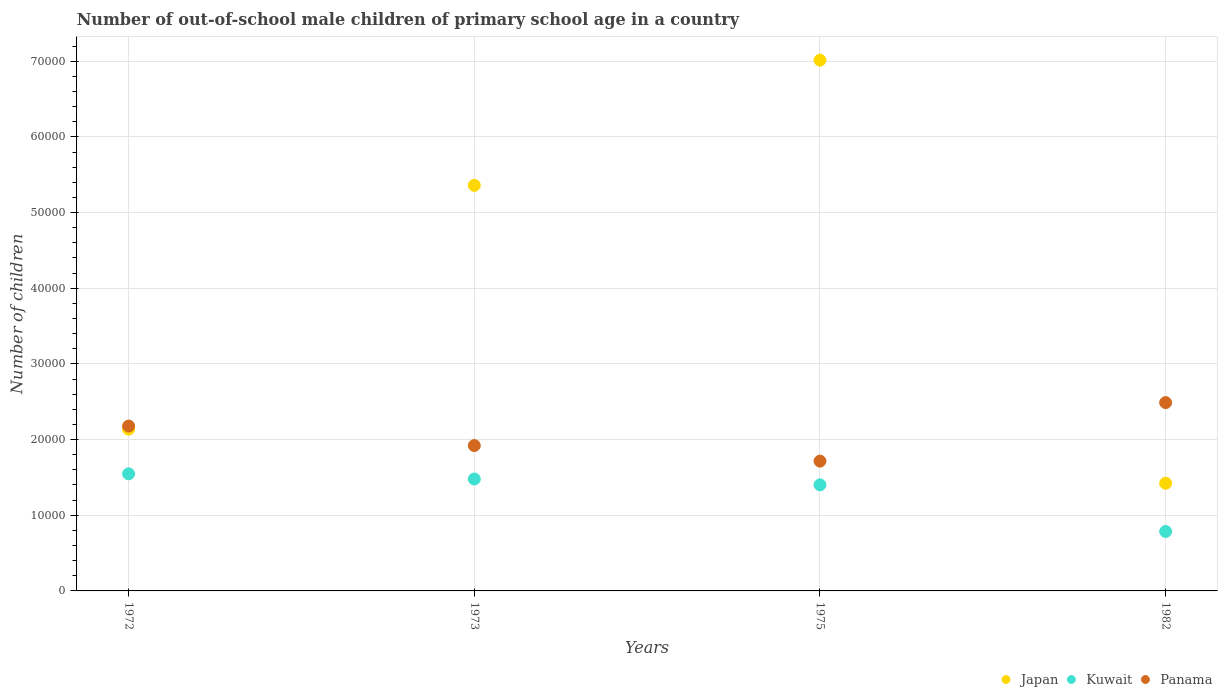Is the number of dotlines equal to the number of legend labels?
Provide a succinct answer. Yes. What is the number of out-of-school male children in Panama in 1975?
Keep it short and to the point. 1.72e+04. Across all years, what is the maximum number of out-of-school male children in Panama?
Ensure brevity in your answer.  2.49e+04. Across all years, what is the minimum number of out-of-school male children in Japan?
Provide a succinct answer. 1.42e+04. In which year was the number of out-of-school male children in Japan maximum?
Ensure brevity in your answer.  1975. In which year was the number of out-of-school male children in Panama minimum?
Offer a very short reply. 1975. What is the total number of out-of-school male children in Panama in the graph?
Offer a terse response. 8.30e+04. What is the difference between the number of out-of-school male children in Kuwait in 1975 and that in 1982?
Give a very brief answer. 6163. What is the difference between the number of out-of-school male children in Panama in 1973 and the number of out-of-school male children in Kuwait in 1972?
Make the answer very short. 3737. What is the average number of out-of-school male children in Kuwait per year?
Your answer should be very brief. 1.30e+04. In the year 1975, what is the difference between the number of out-of-school male children in Panama and number of out-of-school male children in Japan?
Keep it short and to the point. -5.30e+04. In how many years, is the number of out-of-school male children in Panama greater than 50000?
Offer a very short reply. 0. What is the ratio of the number of out-of-school male children in Japan in 1973 to that in 1982?
Your answer should be very brief. 3.77. Is the number of out-of-school male children in Panama in 1973 less than that in 1982?
Provide a short and direct response. Yes. Is the difference between the number of out-of-school male children in Panama in 1975 and 1982 greater than the difference between the number of out-of-school male children in Japan in 1975 and 1982?
Your response must be concise. No. What is the difference between the highest and the second highest number of out-of-school male children in Japan?
Your answer should be very brief. 1.65e+04. What is the difference between the highest and the lowest number of out-of-school male children in Panama?
Offer a very short reply. 7733. In how many years, is the number of out-of-school male children in Panama greater than the average number of out-of-school male children in Panama taken over all years?
Your response must be concise. 2. Is the sum of the number of out-of-school male children in Panama in 1973 and 1975 greater than the maximum number of out-of-school male children in Kuwait across all years?
Give a very brief answer. Yes. How many dotlines are there?
Give a very brief answer. 3. How many years are there in the graph?
Provide a succinct answer. 4. Are the values on the major ticks of Y-axis written in scientific E-notation?
Your response must be concise. No. Does the graph contain any zero values?
Ensure brevity in your answer.  No. Does the graph contain grids?
Offer a terse response. Yes. How many legend labels are there?
Your answer should be compact. 3. How are the legend labels stacked?
Provide a short and direct response. Horizontal. What is the title of the graph?
Your response must be concise. Number of out-of-school male children of primary school age in a country. Does "Philippines" appear as one of the legend labels in the graph?
Ensure brevity in your answer.  No. What is the label or title of the X-axis?
Provide a short and direct response. Years. What is the label or title of the Y-axis?
Provide a succinct answer. Number of children. What is the Number of children in Japan in 1972?
Your response must be concise. 2.14e+04. What is the Number of children in Kuwait in 1972?
Ensure brevity in your answer.  1.55e+04. What is the Number of children in Panama in 1972?
Offer a terse response. 2.18e+04. What is the Number of children of Japan in 1973?
Your answer should be compact. 5.36e+04. What is the Number of children of Kuwait in 1973?
Offer a terse response. 1.48e+04. What is the Number of children in Panama in 1973?
Offer a terse response. 1.92e+04. What is the Number of children in Japan in 1975?
Offer a terse response. 7.01e+04. What is the Number of children in Kuwait in 1975?
Offer a terse response. 1.40e+04. What is the Number of children in Panama in 1975?
Your response must be concise. 1.72e+04. What is the Number of children in Japan in 1982?
Make the answer very short. 1.42e+04. What is the Number of children of Kuwait in 1982?
Provide a succinct answer. 7856. What is the Number of children of Panama in 1982?
Your answer should be compact. 2.49e+04. Across all years, what is the maximum Number of children of Japan?
Your response must be concise. 7.01e+04. Across all years, what is the maximum Number of children of Kuwait?
Your answer should be compact. 1.55e+04. Across all years, what is the maximum Number of children in Panama?
Offer a terse response. 2.49e+04. Across all years, what is the minimum Number of children in Japan?
Keep it short and to the point. 1.42e+04. Across all years, what is the minimum Number of children in Kuwait?
Keep it short and to the point. 7856. Across all years, what is the minimum Number of children of Panama?
Provide a short and direct response. 1.72e+04. What is the total Number of children of Japan in the graph?
Make the answer very short. 1.59e+05. What is the total Number of children in Kuwait in the graph?
Your answer should be very brief. 5.21e+04. What is the total Number of children in Panama in the graph?
Your answer should be compact. 8.30e+04. What is the difference between the Number of children of Japan in 1972 and that in 1973?
Provide a succinct answer. -3.22e+04. What is the difference between the Number of children of Kuwait in 1972 and that in 1973?
Provide a short and direct response. 681. What is the difference between the Number of children of Panama in 1972 and that in 1973?
Provide a short and direct response. 2577. What is the difference between the Number of children in Japan in 1972 and that in 1975?
Provide a short and direct response. -4.88e+04. What is the difference between the Number of children in Kuwait in 1972 and that in 1975?
Provide a succinct answer. 1454. What is the difference between the Number of children of Panama in 1972 and that in 1975?
Make the answer very short. 4635. What is the difference between the Number of children of Japan in 1972 and that in 1982?
Make the answer very short. 7146. What is the difference between the Number of children of Kuwait in 1972 and that in 1982?
Ensure brevity in your answer.  7617. What is the difference between the Number of children in Panama in 1972 and that in 1982?
Your response must be concise. -3098. What is the difference between the Number of children of Japan in 1973 and that in 1975?
Keep it short and to the point. -1.65e+04. What is the difference between the Number of children in Kuwait in 1973 and that in 1975?
Your response must be concise. 773. What is the difference between the Number of children in Panama in 1973 and that in 1975?
Offer a terse response. 2058. What is the difference between the Number of children in Japan in 1973 and that in 1982?
Ensure brevity in your answer.  3.94e+04. What is the difference between the Number of children in Kuwait in 1973 and that in 1982?
Offer a very short reply. 6936. What is the difference between the Number of children of Panama in 1973 and that in 1982?
Provide a succinct answer. -5675. What is the difference between the Number of children in Japan in 1975 and that in 1982?
Offer a very short reply. 5.59e+04. What is the difference between the Number of children in Kuwait in 1975 and that in 1982?
Provide a short and direct response. 6163. What is the difference between the Number of children of Panama in 1975 and that in 1982?
Your response must be concise. -7733. What is the difference between the Number of children in Japan in 1972 and the Number of children in Kuwait in 1973?
Make the answer very short. 6585. What is the difference between the Number of children in Japan in 1972 and the Number of children in Panama in 1973?
Make the answer very short. 2167. What is the difference between the Number of children of Kuwait in 1972 and the Number of children of Panama in 1973?
Your answer should be compact. -3737. What is the difference between the Number of children of Japan in 1972 and the Number of children of Kuwait in 1975?
Keep it short and to the point. 7358. What is the difference between the Number of children of Japan in 1972 and the Number of children of Panama in 1975?
Provide a short and direct response. 4225. What is the difference between the Number of children in Kuwait in 1972 and the Number of children in Panama in 1975?
Offer a terse response. -1679. What is the difference between the Number of children of Japan in 1972 and the Number of children of Kuwait in 1982?
Keep it short and to the point. 1.35e+04. What is the difference between the Number of children in Japan in 1972 and the Number of children in Panama in 1982?
Your response must be concise. -3508. What is the difference between the Number of children in Kuwait in 1972 and the Number of children in Panama in 1982?
Your answer should be very brief. -9412. What is the difference between the Number of children of Japan in 1973 and the Number of children of Kuwait in 1975?
Provide a succinct answer. 3.96e+04. What is the difference between the Number of children of Japan in 1973 and the Number of children of Panama in 1975?
Your response must be concise. 3.64e+04. What is the difference between the Number of children of Kuwait in 1973 and the Number of children of Panama in 1975?
Provide a succinct answer. -2360. What is the difference between the Number of children in Japan in 1973 and the Number of children in Kuwait in 1982?
Provide a succinct answer. 4.57e+04. What is the difference between the Number of children of Japan in 1973 and the Number of children of Panama in 1982?
Ensure brevity in your answer.  2.87e+04. What is the difference between the Number of children of Kuwait in 1973 and the Number of children of Panama in 1982?
Your response must be concise. -1.01e+04. What is the difference between the Number of children of Japan in 1975 and the Number of children of Kuwait in 1982?
Your answer should be compact. 6.23e+04. What is the difference between the Number of children of Japan in 1975 and the Number of children of Panama in 1982?
Offer a very short reply. 4.53e+04. What is the difference between the Number of children of Kuwait in 1975 and the Number of children of Panama in 1982?
Keep it short and to the point. -1.09e+04. What is the average Number of children of Japan per year?
Your answer should be very brief. 3.98e+04. What is the average Number of children of Kuwait per year?
Your answer should be compact. 1.30e+04. What is the average Number of children of Panama per year?
Give a very brief answer. 2.08e+04. In the year 1972, what is the difference between the Number of children in Japan and Number of children in Kuwait?
Ensure brevity in your answer.  5904. In the year 1972, what is the difference between the Number of children in Japan and Number of children in Panama?
Your answer should be very brief. -410. In the year 1972, what is the difference between the Number of children in Kuwait and Number of children in Panama?
Your response must be concise. -6314. In the year 1973, what is the difference between the Number of children in Japan and Number of children in Kuwait?
Your response must be concise. 3.88e+04. In the year 1973, what is the difference between the Number of children in Japan and Number of children in Panama?
Keep it short and to the point. 3.44e+04. In the year 1973, what is the difference between the Number of children of Kuwait and Number of children of Panama?
Provide a succinct answer. -4418. In the year 1975, what is the difference between the Number of children of Japan and Number of children of Kuwait?
Your answer should be very brief. 5.61e+04. In the year 1975, what is the difference between the Number of children of Japan and Number of children of Panama?
Keep it short and to the point. 5.30e+04. In the year 1975, what is the difference between the Number of children of Kuwait and Number of children of Panama?
Keep it short and to the point. -3133. In the year 1982, what is the difference between the Number of children in Japan and Number of children in Kuwait?
Offer a very short reply. 6375. In the year 1982, what is the difference between the Number of children of Japan and Number of children of Panama?
Provide a succinct answer. -1.07e+04. In the year 1982, what is the difference between the Number of children of Kuwait and Number of children of Panama?
Give a very brief answer. -1.70e+04. What is the ratio of the Number of children in Japan in 1972 to that in 1973?
Keep it short and to the point. 0.4. What is the ratio of the Number of children in Kuwait in 1972 to that in 1973?
Provide a short and direct response. 1.05. What is the ratio of the Number of children of Panama in 1972 to that in 1973?
Provide a succinct answer. 1.13. What is the ratio of the Number of children of Japan in 1972 to that in 1975?
Your answer should be compact. 0.3. What is the ratio of the Number of children of Kuwait in 1972 to that in 1975?
Offer a very short reply. 1.1. What is the ratio of the Number of children in Panama in 1972 to that in 1975?
Keep it short and to the point. 1.27. What is the ratio of the Number of children in Japan in 1972 to that in 1982?
Offer a terse response. 1.5. What is the ratio of the Number of children of Kuwait in 1972 to that in 1982?
Keep it short and to the point. 1.97. What is the ratio of the Number of children of Panama in 1972 to that in 1982?
Ensure brevity in your answer.  0.88. What is the ratio of the Number of children of Japan in 1973 to that in 1975?
Offer a terse response. 0.76. What is the ratio of the Number of children in Kuwait in 1973 to that in 1975?
Ensure brevity in your answer.  1.06. What is the ratio of the Number of children of Panama in 1973 to that in 1975?
Provide a succinct answer. 1.12. What is the ratio of the Number of children in Japan in 1973 to that in 1982?
Provide a short and direct response. 3.77. What is the ratio of the Number of children in Kuwait in 1973 to that in 1982?
Your answer should be compact. 1.88. What is the ratio of the Number of children in Panama in 1973 to that in 1982?
Provide a succinct answer. 0.77. What is the ratio of the Number of children of Japan in 1975 to that in 1982?
Offer a terse response. 4.93. What is the ratio of the Number of children of Kuwait in 1975 to that in 1982?
Offer a very short reply. 1.78. What is the ratio of the Number of children in Panama in 1975 to that in 1982?
Provide a succinct answer. 0.69. What is the difference between the highest and the second highest Number of children of Japan?
Offer a very short reply. 1.65e+04. What is the difference between the highest and the second highest Number of children in Kuwait?
Offer a terse response. 681. What is the difference between the highest and the second highest Number of children in Panama?
Your answer should be compact. 3098. What is the difference between the highest and the lowest Number of children of Japan?
Offer a terse response. 5.59e+04. What is the difference between the highest and the lowest Number of children in Kuwait?
Your answer should be compact. 7617. What is the difference between the highest and the lowest Number of children of Panama?
Ensure brevity in your answer.  7733. 